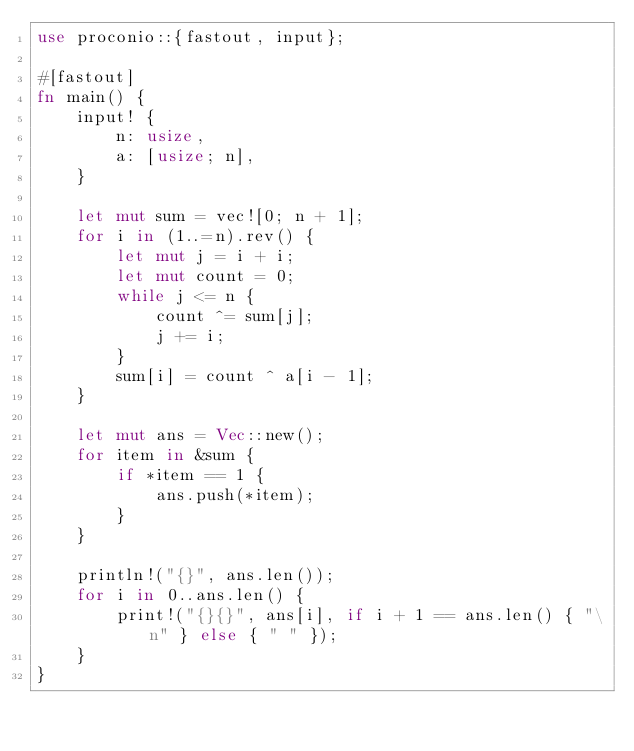<code> <loc_0><loc_0><loc_500><loc_500><_Rust_>use proconio::{fastout, input};

#[fastout]
fn main() {
    input! {
        n: usize,
        a: [usize; n],
    }

    let mut sum = vec![0; n + 1];
    for i in (1..=n).rev() {
        let mut j = i + i;
        let mut count = 0;
        while j <= n {
            count ^= sum[j];
            j += i;
        }
        sum[i] = count ^ a[i - 1];
    }

    let mut ans = Vec::new();
    for item in &sum {
        if *item == 1 {
            ans.push(*item);
        }
    }

    println!("{}", ans.len());
    for i in 0..ans.len() {
        print!("{}{}", ans[i], if i + 1 == ans.len() { "\n" } else { " " });
    }
}
</code> 